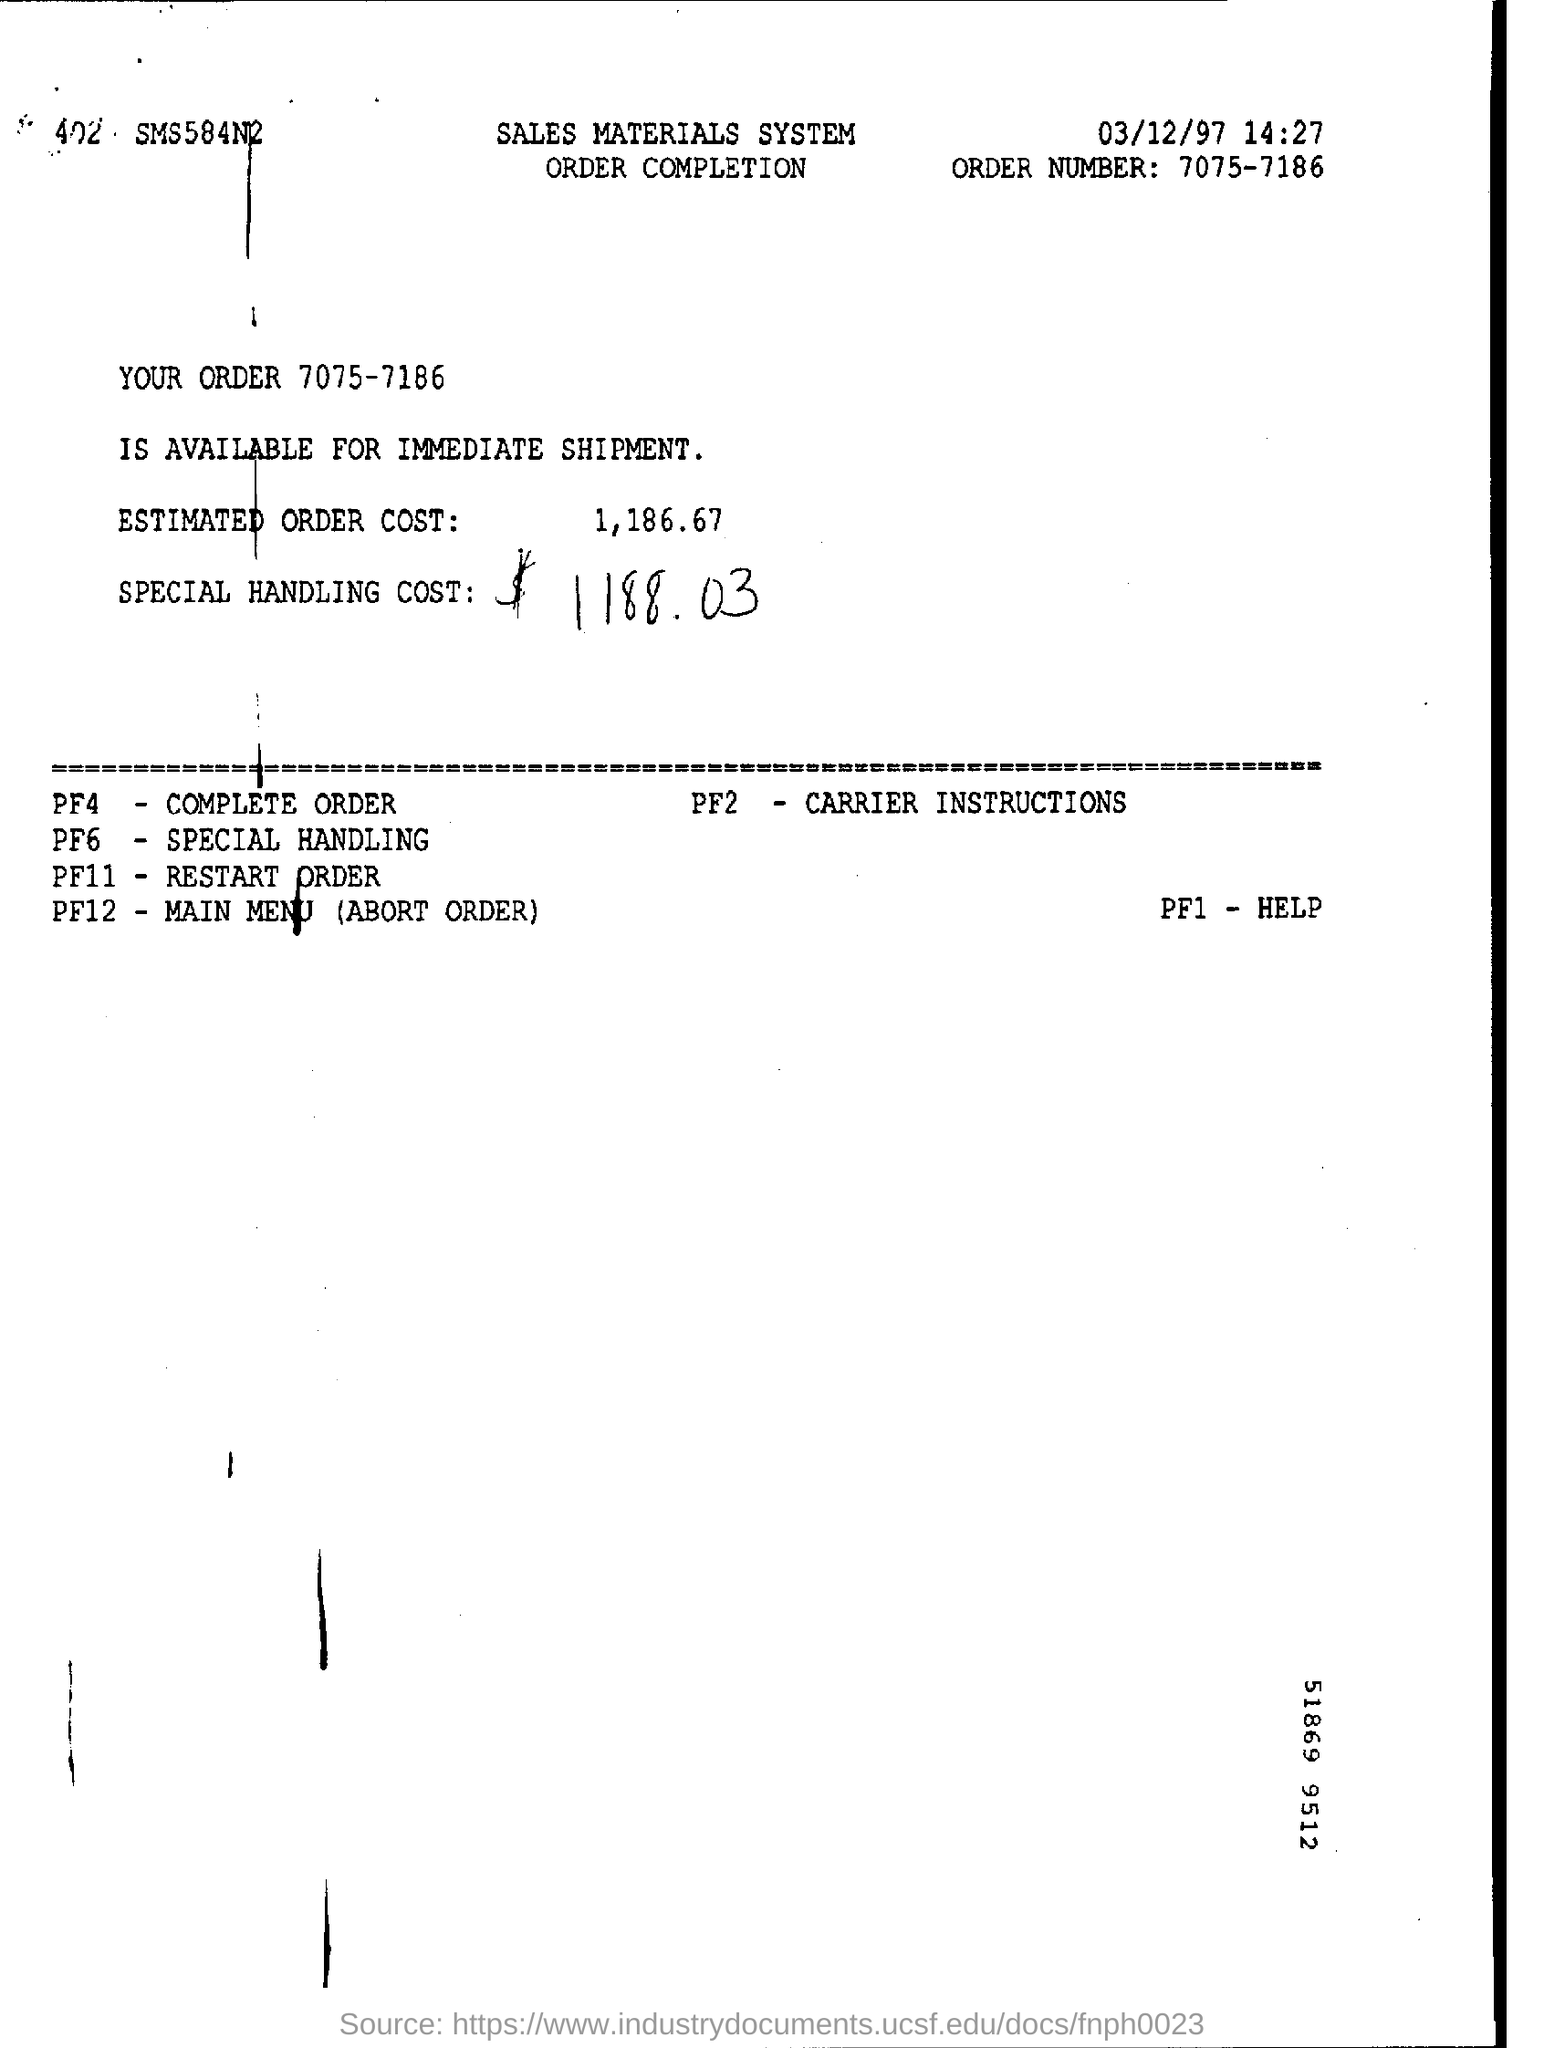What is the Title of the document ?
Ensure brevity in your answer.  SALES MATERIALS SYSTEM ORDER COMPLETION. What is the ORDER NUMBER ?
Your answer should be compact. 7075-7186. What is written in the PF11 Field ?
Offer a terse response. RESTART ORDER. What is the Code for CARRIER INSTRUCTIONS ?
Your answer should be compact. PF2. 